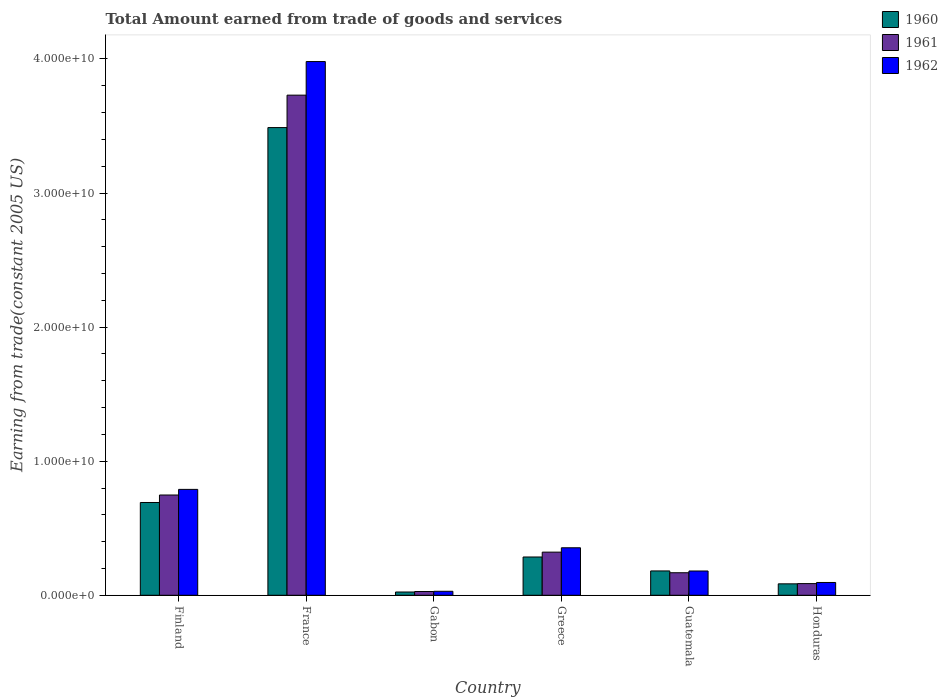How many different coloured bars are there?
Offer a terse response. 3. How many groups of bars are there?
Your answer should be very brief. 6. Are the number of bars on each tick of the X-axis equal?
Give a very brief answer. Yes. How many bars are there on the 6th tick from the left?
Your answer should be very brief. 3. What is the label of the 5th group of bars from the left?
Offer a terse response. Guatemala. What is the total amount earned by trading goods and services in 1962 in France?
Provide a short and direct response. 3.98e+1. Across all countries, what is the maximum total amount earned by trading goods and services in 1962?
Give a very brief answer. 3.98e+1. Across all countries, what is the minimum total amount earned by trading goods and services in 1960?
Keep it short and to the point. 2.44e+08. In which country was the total amount earned by trading goods and services in 1960 maximum?
Provide a succinct answer. France. In which country was the total amount earned by trading goods and services in 1961 minimum?
Offer a terse response. Gabon. What is the total total amount earned by trading goods and services in 1961 in the graph?
Your answer should be compact. 5.08e+1. What is the difference between the total amount earned by trading goods and services in 1960 in Finland and that in France?
Provide a short and direct response. -2.80e+1. What is the difference between the total amount earned by trading goods and services in 1961 in Guatemala and the total amount earned by trading goods and services in 1962 in Greece?
Provide a succinct answer. -1.86e+09. What is the average total amount earned by trading goods and services in 1961 per country?
Offer a terse response. 8.47e+09. What is the difference between the total amount earned by trading goods and services of/in 1960 and total amount earned by trading goods and services of/in 1962 in France?
Provide a short and direct response. -4.92e+09. What is the ratio of the total amount earned by trading goods and services in 1962 in France to that in Greece?
Offer a very short reply. 11.24. Is the total amount earned by trading goods and services in 1960 in Guatemala less than that in Honduras?
Your response must be concise. No. What is the difference between the highest and the second highest total amount earned by trading goods and services in 1962?
Make the answer very short. 3.63e+1. What is the difference between the highest and the lowest total amount earned by trading goods and services in 1960?
Your response must be concise. 3.46e+1. In how many countries, is the total amount earned by trading goods and services in 1962 greater than the average total amount earned by trading goods and services in 1962 taken over all countries?
Offer a terse response. 1. Is the sum of the total amount earned by trading goods and services in 1962 in France and Greece greater than the maximum total amount earned by trading goods and services in 1960 across all countries?
Provide a succinct answer. Yes. What does the 3rd bar from the right in Finland represents?
Keep it short and to the point. 1960. Are all the bars in the graph horizontal?
Provide a succinct answer. No. How many countries are there in the graph?
Your answer should be compact. 6. Are the values on the major ticks of Y-axis written in scientific E-notation?
Keep it short and to the point. Yes. How many legend labels are there?
Give a very brief answer. 3. How are the legend labels stacked?
Provide a short and direct response. Vertical. What is the title of the graph?
Your answer should be very brief. Total Amount earned from trade of goods and services. Does "2013" appear as one of the legend labels in the graph?
Ensure brevity in your answer.  No. What is the label or title of the X-axis?
Offer a very short reply. Country. What is the label or title of the Y-axis?
Keep it short and to the point. Earning from trade(constant 2005 US). What is the Earning from trade(constant 2005 US) of 1960 in Finland?
Your response must be concise. 6.92e+09. What is the Earning from trade(constant 2005 US) of 1961 in Finland?
Offer a terse response. 7.48e+09. What is the Earning from trade(constant 2005 US) of 1962 in Finland?
Keep it short and to the point. 7.90e+09. What is the Earning from trade(constant 2005 US) of 1960 in France?
Your answer should be compact. 3.49e+1. What is the Earning from trade(constant 2005 US) of 1961 in France?
Make the answer very short. 3.73e+1. What is the Earning from trade(constant 2005 US) in 1962 in France?
Your response must be concise. 3.98e+1. What is the Earning from trade(constant 2005 US) of 1960 in Gabon?
Your answer should be very brief. 2.44e+08. What is the Earning from trade(constant 2005 US) of 1961 in Gabon?
Provide a succinct answer. 2.80e+08. What is the Earning from trade(constant 2005 US) of 1962 in Gabon?
Keep it short and to the point. 2.97e+08. What is the Earning from trade(constant 2005 US) of 1960 in Greece?
Provide a short and direct response. 2.85e+09. What is the Earning from trade(constant 2005 US) in 1961 in Greece?
Keep it short and to the point. 3.22e+09. What is the Earning from trade(constant 2005 US) of 1962 in Greece?
Ensure brevity in your answer.  3.54e+09. What is the Earning from trade(constant 2005 US) of 1960 in Guatemala?
Offer a very short reply. 1.82e+09. What is the Earning from trade(constant 2005 US) in 1961 in Guatemala?
Your answer should be very brief. 1.68e+09. What is the Earning from trade(constant 2005 US) of 1962 in Guatemala?
Give a very brief answer. 1.81e+09. What is the Earning from trade(constant 2005 US) in 1960 in Honduras?
Ensure brevity in your answer.  8.53e+08. What is the Earning from trade(constant 2005 US) in 1961 in Honduras?
Ensure brevity in your answer.  8.71e+08. What is the Earning from trade(constant 2005 US) in 1962 in Honduras?
Your answer should be compact. 9.55e+08. Across all countries, what is the maximum Earning from trade(constant 2005 US) in 1960?
Your response must be concise. 3.49e+1. Across all countries, what is the maximum Earning from trade(constant 2005 US) of 1961?
Make the answer very short. 3.73e+1. Across all countries, what is the maximum Earning from trade(constant 2005 US) of 1962?
Keep it short and to the point. 3.98e+1. Across all countries, what is the minimum Earning from trade(constant 2005 US) in 1960?
Your answer should be very brief. 2.44e+08. Across all countries, what is the minimum Earning from trade(constant 2005 US) in 1961?
Your answer should be compact. 2.80e+08. Across all countries, what is the minimum Earning from trade(constant 2005 US) in 1962?
Your answer should be very brief. 2.97e+08. What is the total Earning from trade(constant 2005 US) of 1960 in the graph?
Offer a very short reply. 4.76e+1. What is the total Earning from trade(constant 2005 US) in 1961 in the graph?
Offer a very short reply. 5.08e+1. What is the total Earning from trade(constant 2005 US) in 1962 in the graph?
Offer a very short reply. 5.43e+1. What is the difference between the Earning from trade(constant 2005 US) of 1960 in Finland and that in France?
Give a very brief answer. -2.80e+1. What is the difference between the Earning from trade(constant 2005 US) of 1961 in Finland and that in France?
Make the answer very short. -2.98e+1. What is the difference between the Earning from trade(constant 2005 US) of 1962 in Finland and that in France?
Make the answer very short. -3.19e+1. What is the difference between the Earning from trade(constant 2005 US) of 1960 in Finland and that in Gabon?
Your answer should be very brief. 6.68e+09. What is the difference between the Earning from trade(constant 2005 US) in 1961 in Finland and that in Gabon?
Ensure brevity in your answer.  7.20e+09. What is the difference between the Earning from trade(constant 2005 US) in 1962 in Finland and that in Gabon?
Provide a short and direct response. 7.60e+09. What is the difference between the Earning from trade(constant 2005 US) in 1960 in Finland and that in Greece?
Give a very brief answer. 4.07e+09. What is the difference between the Earning from trade(constant 2005 US) of 1961 in Finland and that in Greece?
Give a very brief answer. 4.26e+09. What is the difference between the Earning from trade(constant 2005 US) in 1962 in Finland and that in Greece?
Keep it short and to the point. 4.35e+09. What is the difference between the Earning from trade(constant 2005 US) in 1960 in Finland and that in Guatemala?
Give a very brief answer. 5.11e+09. What is the difference between the Earning from trade(constant 2005 US) in 1961 in Finland and that in Guatemala?
Your answer should be compact. 5.80e+09. What is the difference between the Earning from trade(constant 2005 US) of 1962 in Finland and that in Guatemala?
Your response must be concise. 6.09e+09. What is the difference between the Earning from trade(constant 2005 US) of 1960 in Finland and that in Honduras?
Make the answer very short. 6.07e+09. What is the difference between the Earning from trade(constant 2005 US) of 1961 in Finland and that in Honduras?
Your response must be concise. 6.61e+09. What is the difference between the Earning from trade(constant 2005 US) in 1962 in Finland and that in Honduras?
Ensure brevity in your answer.  6.94e+09. What is the difference between the Earning from trade(constant 2005 US) in 1960 in France and that in Gabon?
Ensure brevity in your answer.  3.46e+1. What is the difference between the Earning from trade(constant 2005 US) of 1961 in France and that in Gabon?
Give a very brief answer. 3.70e+1. What is the difference between the Earning from trade(constant 2005 US) of 1962 in France and that in Gabon?
Offer a terse response. 3.95e+1. What is the difference between the Earning from trade(constant 2005 US) in 1960 in France and that in Greece?
Give a very brief answer. 3.20e+1. What is the difference between the Earning from trade(constant 2005 US) in 1961 in France and that in Greece?
Offer a terse response. 3.41e+1. What is the difference between the Earning from trade(constant 2005 US) of 1962 in France and that in Greece?
Offer a terse response. 3.63e+1. What is the difference between the Earning from trade(constant 2005 US) in 1960 in France and that in Guatemala?
Make the answer very short. 3.31e+1. What is the difference between the Earning from trade(constant 2005 US) in 1961 in France and that in Guatemala?
Offer a terse response. 3.56e+1. What is the difference between the Earning from trade(constant 2005 US) in 1962 in France and that in Guatemala?
Make the answer very short. 3.80e+1. What is the difference between the Earning from trade(constant 2005 US) in 1960 in France and that in Honduras?
Your answer should be very brief. 3.40e+1. What is the difference between the Earning from trade(constant 2005 US) in 1961 in France and that in Honduras?
Your answer should be compact. 3.64e+1. What is the difference between the Earning from trade(constant 2005 US) of 1962 in France and that in Honduras?
Make the answer very short. 3.89e+1. What is the difference between the Earning from trade(constant 2005 US) of 1960 in Gabon and that in Greece?
Your response must be concise. -2.61e+09. What is the difference between the Earning from trade(constant 2005 US) of 1961 in Gabon and that in Greece?
Your answer should be very brief. -2.94e+09. What is the difference between the Earning from trade(constant 2005 US) in 1962 in Gabon and that in Greece?
Your answer should be compact. -3.25e+09. What is the difference between the Earning from trade(constant 2005 US) of 1960 in Gabon and that in Guatemala?
Your answer should be compact. -1.57e+09. What is the difference between the Earning from trade(constant 2005 US) of 1961 in Gabon and that in Guatemala?
Ensure brevity in your answer.  -1.40e+09. What is the difference between the Earning from trade(constant 2005 US) in 1962 in Gabon and that in Guatemala?
Give a very brief answer. -1.51e+09. What is the difference between the Earning from trade(constant 2005 US) in 1960 in Gabon and that in Honduras?
Give a very brief answer. -6.09e+08. What is the difference between the Earning from trade(constant 2005 US) in 1961 in Gabon and that in Honduras?
Give a very brief answer. -5.91e+08. What is the difference between the Earning from trade(constant 2005 US) in 1962 in Gabon and that in Honduras?
Offer a terse response. -6.58e+08. What is the difference between the Earning from trade(constant 2005 US) in 1960 in Greece and that in Guatemala?
Make the answer very short. 1.04e+09. What is the difference between the Earning from trade(constant 2005 US) of 1961 in Greece and that in Guatemala?
Make the answer very short. 1.54e+09. What is the difference between the Earning from trade(constant 2005 US) in 1962 in Greece and that in Guatemala?
Give a very brief answer. 1.73e+09. What is the difference between the Earning from trade(constant 2005 US) of 1960 in Greece and that in Honduras?
Offer a very short reply. 2.00e+09. What is the difference between the Earning from trade(constant 2005 US) in 1961 in Greece and that in Honduras?
Provide a succinct answer. 2.35e+09. What is the difference between the Earning from trade(constant 2005 US) of 1962 in Greece and that in Honduras?
Offer a terse response. 2.59e+09. What is the difference between the Earning from trade(constant 2005 US) in 1960 in Guatemala and that in Honduras?
Give a very brief answer. 9.62e+08. What is the difference between the Earning from trade(constant 2005 US) of 1961 in Guatemala and that in Honduras?
Offer a terse response. 8.09e+08. What is the difference between the Earning from trade(constant 2005 US) in 1962 in Guatemala and that in Honduras?
Offer a very short reply. 8.56e+08. What is the difference between the Earning from trade(constant 2005 US) of 1960 in Finland and the Earning from trade(constant 2005 US) of 1961 in France?
Your response must be concise. -3.04e+1. What is the difference between the Earning from trade(constant 2005 US) of 1960 in Finland and the Earning from trade(constant 2005 US) of 1962 in France?
Keep it short and to the point. -3.29e+1. What is the difference between the Earning from trade(constant 2005 US) in 1961 in Finland and the Earning from trade(constant 2005 US) in 1962 in France?
Your response must be concise. -3.23e+1. What is the difference between the Earning from trade(constant 2005 US) in 1960 in Finland and the Earning from trade(constant 2005 US) in 1961 in Gabon?
Provide a succinct answer. 6.64e+09. What is the difference between the Earning from trade(constant 2005 US) in 1960 in Finland and the Earning from trade(constant 2005 US) in 1962 in Gabon?
Your answer should be compact. 6.62e+09. What is the difference between the Earning from trade(constant 2005 US) in 1961 in Finland and the Earning from trade(constant 2005 US) in 1962 in Gabon?
Give a very brief answer. 7.18e+09. What is the difference between the Earning from trade(constant 2005 US) of 1960 in Finland and the Earning from trade(constant 2005 US) of 1961 in Greece?
Offer a very short reply. 3.70e+09. What is the difference between the Earning from trade(constant 2005 US) of 1960 in Finland and the Earning from trade(constant 2005 US) of 1962 in Greece?
Give a very brief answer. 3.38e+09. What is the difference between the Earning from trade(constant 2005 US) of 1961 in Finland and the Earning from trade(constant 2005 US) of 1962 in Greece?
Your answer should be very brief. 3.93e+09. What is the difference between the Earning from trade(constant 2005 US) of 1960 in Finland and the Earning from trade(constant 2005 US) of 1961 in Guatemala?
Your answer should be very brief. 5.24e+09. What is the difference between the Earning from trade(constant 2005 US) of 1960 in Finland and the Earning from trade(constant 2005 US) of 1962 in Guatemala?
Your response must be concise. 5.11e+09. What is the difference between the Earning from trade(constant 2005 US) in 1961 in Finland and the Earning from trade(constant 2005 US) in 1962 in Guatemala?
Provide a succinct answer. 5.67e+09. What is the difference between the Earning from trade(constant 2005 US) of 1960 in Finland and the Earning from trade(constant 2005 US) of 1961 in Honduras?
Keep it short and to the point. 6.05e+09. What is the difference between the Earning from trade(constant 2005 US) of 1960 in Finland and the Earning from trade(constant 2005 US) of 1962 in Honduras?
Give a very brief answer. 5.97e+09. What is the difference between the Earning from trade(constant 2005 US) of 1961 in Finland and the Earning from trade(constant 2005 US) of 1962 in Honduras?
Provide a short and direct response. 6.52e+09. What is the difference between the Earning from trade(constant 2005 US) in 1960 in France and the Earning from trade(constant 2005 US) in 1961 in Gabon?
Make the answer very short. 3.46e+1. What is the difference between the Earning from trade(constant 2005 US) of 1960 in France and the Earning from trade(constant 2005 US) of 1962 in Gabon?
Your answer should be compact. 3.46e+1. What is the difference between the Earning from trade(constant 2005 US) in 1961 in France and the Earning from trade(constant 2005 US) in 1962 in Gabon?
Ensure brevity in your answer.  3.70e+1. What is the difference between the Earning from trade(constant 2005 US) of 1960 in France and the Earning from trade(constant 2005 US) of 1961 in Greece?
Your response must be concise. 3.17e+1. What is the difference between the Earning from trade(constant 2005 US) of 1960 in France and the Earning from trade(constant 2005 US) of 1962 in Greece?
Offer a very short reply. 3.13e+1. What is the difference between the Earning from trade(constant 2005 US) of 1961 in France and the Earning from trade(constant 2005 US) of 1962 in Greece?
Your answer should be compact. 3.38e+1. What is the difference between the Earning from trade(constant 2005 US) in 1960 in France and the Earning from trade(constant 2005 US) in 1961 in Guatemala?
Give a very brief answer. 3.32e+1. What is the difference between the Earning from trade(constant 2005 US) in 1960 in France and the Earning from trade(constant 2005 US) in 1962 in Guatemala?
Provide a succinct answer. 3.31e+1. What is the difference between the Earning from trade(constant 2005 US) in 1961 in France and the Earning from trade(constant 2005 US) in 1962 in Guatemala?
Give a very brief answer. 3.55e+1. What is the difference between the Earning from trade(constant 2005 US) in 1960 in France and the Earning from trade(constant 2005 US) in 1961 in Honduras?
Make the answer very short. 3.40e+1. What is the difference between the Earning from trade(constant 2005 US) of 1960 in France and the Earning from trade(constant 2005 US) of 1962 in Honduras?
Your answer should be compact. 3.39e+1. What is the difference between the Earning from trade(constant 2005 US) of 1961 in France and the Earning from trade(constant 2005 US) of 1962 in Honduras?
Your answer should be compact. 3.63e+1. What is the difference between the Earning from trade(constant 2005 US) of 1960 in Gabon and the Earning from trade(constant 2005 US) of 1961 in Greece?
Your answer should be very brief. -2.97e+09. What is the difference between the Earning from trade(constant 2005 US) of 1960 in Gabon and the Earning from trade(constant 2005 US) of 1962 in Greece?
Provide a short and direct response. -3.30e+09. What is the difference between the Earning from trade(constant 2005 US) in 1961 in Gabon and the Earning from trade(constant 2005 US) in 1962 in Greece?
Offer a terse response. -3.26e+09. What is the difference between the Earning from trade(constant 2005 US) of 1960 in Gabon and the Earning from trade(constant 2005 US) of 1961 in Guatemala?
Give a very brief answer. -1.44e+09. What is the difference between the Earning from trade(constant 2005 US) in 1960 in Gabon and the Earning from trade(constant 2005 US) in 1962 in Guatemala?
Offer a very short reply. -1.57e+09. What is the difference between the Earning from trade(constant 2005 US) of 1961 in Gabon and the Earning from trade(constant 2005 US) of 1962 in Guatemala?
Keep it short and to the point. -1.53e+09. What is the difference between the Earning from trade(constant 2005 US) in 1960 in Gabon and the Earning from trade(constant 2005 US) in 1961 in Honduras?
Make the answer very short. -6.27e+08. What is the difference between the Earning from trade(constant 2005 US) in 1960 in Gabon and the Earning from trade(constant 2005 US) in 1962 in Honduras?
Your answer should be very brief. -7.11e+08. What is the difference between the Earning from trade(constant 2005 US) in 1961 in Gabon and the Earning from trade(constant 2005 US) in 1962 in Honduras?
Offer a terse response. -6.74e+08. What is the difference between the Earning from trade(constant 2005 US) in 1960 in Greece and the Earning from trade(constant 2005 US) in 1961 in Guatemala?
Your answer should be very brief. 1.17e+09. What is the difference between the Earning from trade(constant 2005 US) in 1960 in Greece and the Earning from trade(constant 2005 US) in 1962 in Guatemala?
Offer a terse response. 1.04e+09. What is the difference between the Earning from trade(constant 2005 US) of 1961 in Greece and the Earning from trade(constant 2005 US) of 1962 in Guatemala?
Offer a very short reply. 1.41e+09. What is the difference between the Earning from trade(constant 2005 US) in 1960 in Greece and the Earning from trade(constant 2005 US) in 1961 in Honduras?
Ensure brevity in your answer.  1.98e+09. What is the difference between the Earning from trade(constant 2005 US) of 1960 in Greece and the Earning from trade(constant 2005 US) of 1962 in Honduras?
Keep it short and to the point. 1.90e+09. What is the difference between the Earning from trade(constant 2005 US) in 1961 in Greece and the Earning from trade(constant 2005 US) in 1962 in Honduras?
Give a very brief answer. 2.26e+09. What is the difference between the Earning from trade(constant 2005 US) in 1960 in Guatemala and the Earning from trade(constant 2005 US) in 1961 in Honduras?
Make the answer very short. 9.44e+08. What is the difference between the Earning from trade(constant 2005 US) of 1960 in Guatemala and the Earning from trade(constant 2005 US) of 1962 in Honduras?
Your answer should be very brief. 8.61e+08. What is the difference between the Earning from trade(constant 2005 US) of 1961 in Guatemala and the Earning from trade(constant 2005 US) of 1962 in Honduras?
Make the answer very short. 7.26e+08. What is the average Earning from trade(constant 2005 US) in 1960 per country?
Keep it short and to the point. 7.93e+09. What is the average Earning from trade(constant 2005 US) in 1961 per country?
Provide a succinct answer. 8.47e+09. What is the average Earning from trade(constant 2005 US) in 1962 per country?
Make the answer very short. 9.05e+09. What is the difference between the Earning from trade(constant 2005 US) in 1960 and Earning from trade(constant 2005 US) in 1961 in Finland?
Offer a terse response. -5.58e+08. What is the difference between the Earning from trade(constant 2005 US) of 1960 and Earning from trade(constant 2005 US) of 1962 in Finland?
Provide a short and direct response. -9.78e+08. What is the difference between the Earning from trade(constant 2005 US) in 1961 and Earning from trade(constant 2005 US) in 1962 in Finland?
Give a very brief answer. -4.20e+08. What is the difference between the Earning from trade(constant 2005 US) in 1960 and Earning from trade(constant 2005 US) in 1961 in France?
Your answer should be compact. -2.42e+09. What is the difference between the Earning from trade(constant 2005 US) of 1960 and Earning from trade(constant 2005 US) of 1962 in France?
Your answer should be very brief. -4.92e+09. What is the difference between the Earning from trade(constant 2005 US) of 1961 and Earning from trade(constant 2005 US) of 1962 in France?
Make the answer very short. -2.50e+09. What is the difference between the Earning from trade(constant 2005 US) of 1960 and Earning from trade(constant 2005 US) of 1961 in Gabon?
Offer a very short reply. -3.66e+07. What is the difference between the Earning from trade(constant 2005 US) of 1960 and Earning from trade(constant 2005 US) of 1962 in Gabon?
Provide a succinct answer. -5.31e+07. What is the difference between the Earning from trade(constant 2005 US) in 1961 and Earning from trade(constant 2005 US) in 1962 in Gabon?
Provide a short and direct response. -1.64e+07. What is the difference between the Earning from trade(constant 2005 US) of 1960 and Earning from trade(constant 2005 US) of 1961 in Greece?
Offer a terse response. -3.63e+08. What is the difference between the Earning from trade(constant 2005 US) of 1960 and Earning from trade(constant 2005 US) of 1962 in Greece?
Ensure brevity in your answer.  -6.88e+08. What is the difference between the Earning from trade(constant 2005 US) in 1961 and Earning from trade(constant 2005 US) in 1962 in Greece?
Give a very brief answer. -3.25e+08. What is the difference between the Earning from trade(constant 2005 US) of 1960 and Earning from trade(constant 2005 US) of 1961 in Guatemala?
Your answer should be compact. 1.35e+08. What is the difference between the Earning from trade(constant 2005 US) of 1960 and Earning from trade(constant 2005 US) of 1962 in Guatemala?
Make the answer very short. 4.40e+06. What is the difference between the Earning from trade(constant 2005 US) in 1961 and Earning from trade(constant 2005 US) in 1962 in Guatemala?
Your answer should be compact. -1.31e+08. What is the difference between the Earning from trade(constant 2005 US) of 1960 and Earning from trade(constant 2005 US) of 1961 in Honduras?
Give a very brief answer. -1.81e+07. What is the difference between the Earning from trade(constant 2005 US) of 1960 and Earning from trade(constant 2005 US) of 1962 in Honduras?
Provide a short and direct response. -1.02e+08. What is the difference between the Earning from trade(constant 2005 US) in 1961 and Earning from trade(constant 2005 US) in 1962 in Honduras?
Offer a very short reply. -8.35e+07. What is the ratio of the Earning from trade(constant 2005 US) in 1960 in Finland to that in France?
Make the answer very short. 0.2. What is the ratio of the Earning from trade(constant 2005 US) in 1961 in Finland to that in France?
Ensure brevity in your answer.  0.2. What is the ratio of the Earning from trade(constant 2005 US) in 1962 in Finland to that in France?
Give a very brief answer. 0.2. What is the ratio of the Earning from trade(constant 2005 US) in 1960 in Finland to that in Gabon?
Your answer should be compact. 28.38. What is the ratio of the Earning from trade(constant 2005 US) in 1961 in Finland to that in Gabon?
Keep it short and to the point. 26.67. What is the ratio of the Earning from trade(constant 2005 US) in 1962 in Finland to that in Gabon?
Ensure brevity in your answer.  26.6. What is the ratio of the Earning from trade(constant 2005 US) in 1960 in Finland to that in Greece?
Your response must be concise. 2.42. What is the ratio of the Earning from trade(constant 2005 US) of 1961 in Finland to that in Greece?
Your answer should be compact. 2.32. What is the ratio of the Earning from trade(constant 2005 US) of 1962 in Finland to that in Greece?
Provide a succinct answer. 2.23. What is the ratio of the Earning from trade(constant 2005 US) of 1960 in Finland to that in Guatemala?
Make the answer very short. 3.81. What is the ratio of the Earning from trade(constant 2005 US) in 1961 in Finland to that in Guatemala?
Offer a terse response. 4.45. What is the ratio of the Earning from trade(constant 2005 US) of 1962 in Finland to that in Guatemala?
Your response must be concise. 4.36. What is the ratio of the Earning from trade(constant 2005 US) of 1960 in Finland to that in Honduras?
Your response must be concise. 8.11. What is the ratio of the Earning from trade(constant 2005 US) in 1961 in Finland to that in Honduras?
Provide a succinct answer. 8.58. What is the ratio of the Earning from trade(constant 2005 US) of 1962 in Finland to that in Honduras?
Ensure brevity in your answer.  8.27. What is the ratio of the Earning from trade(constant 2005 US) in 1960 in France to that in Gabon?
Offer a terse response. 143.08. What is the ratio of the Earning from trade(constant 2005 US) of 1961 in France to that in Gabon?
Offer a terse response. 133.02. What is the ratio of the Earning from trade(constant 2005 US) of 1962 in France to that in Gabon?
Your answer should be compact. 134.1. What is the ratio of the Earning from trade(constant 2005 US) of 1960 in France to that in Greece?
Your answer should be compact. 12.22. What is the ratio of the Earning from trade(constant 2005 US) of 1961 in France to that in Greece?
Give a very brief answer. 11.59. What is the ratio of the Earning from trade(constant 2005 US) in 1962 in France to that in Greece?
Offer a terse response. 11.24. What is the ratio of the Earning from trade(constant 2005 US) of 1960 in France to that in Guatemala?
Ensure brevity in your answer.  19.22. What is the ratio of the Earning from trade(constant 2005 US) of 1961 in France to that in Guatemala?
Make the answer very short. 22.2. What is the ratio of the Earning from trade(constant 2005 US) of 1962 in France to that in Guatemala?
Your answer should be compact. 21.98. What is the ratio of the Earning from trade(constant 2005 US) of 1960 in France to that in Honduras?
Provide a short and direct response. 40.9. What is the ratio of the Earning from trade(constant 2005 US) of 1961 in France to that in Honduras?
Your response must be concise. 42.82. What is the ratio of the Earning from trade(constant 2005 US) in 1962 in France to that in Honduras?
Ensure brevity in your answer.  41.7. What is the ratio of the Earning from trade(constant 2005 US) in 1960 in Gabon to that in Greece?
Your response must be concise. 0.09. What is the ratio of the Earning from trade(constant 2005 US) in 1961 in Gabon to that in Greece?
Ensure brevity in your answer.  0.09. What is the ratio of the Earning from trade(constant 2005 US) of 1962 in Gabon to that in Greece?
Provide a succinct answer. 0.08. What is the ratio of the Earning from trade(constant 2005 US) of 1960 in Gabon to that in Guatemala?
Keep it short and to the point. 0.13. What is the ratio of the Earning from trade(constant 2005 US) of 1961 in Gabon to that in Guatemala?
Ensure brevity in your answer.  0.17. What is the ratio of the Earning from trade(constant 2005 US) of 1962 in Gabon to that in Guatemala?
Keep it short and to the point. 0.16. What is the ratio of the Earning from trade(constant 2005 US) of 1960 in Gabon to that in Honduras?
Provide a succinct answer. 0.29. What is the ratio of the Earning from trade(constant 2005 US) in 1961 in Gabon to that in Honduras?
Provide a short and direct response. 0.32. What is the ratio of the Earning from trade(constant 2005 US) of 1962 in Gabon to that in Honduras?
Make the answer very short. 0.31. What is the ratio of the Earning from trade(constant 2005 US) of 1960 in Greece to that in Guatemala?
Ensure brevity in your answer.  1.57. What is the ratio of the Earning from trade(constant 2005 US) in 1961 in Greece to that in Guatemala?
Your answer should be very brief. 1.92. What is the ratio of the Earning from trade(constant 2005 US) of 1962 in Greece to that in Guatemala?
Ensure brevity in your answer.  1.96. What is the ratio of the Earning from trade(constant 2005 US) in 1960 in Greece to that in Honduras?
Give a very brief answer. 3.35. What is the ratio of the Earning from trade(constant 2005 US) in 1961 in Greece to that in Honduras?
Your answer should be compact. 3.69. What is the ratio of the Earning from trade(constant 2005 US) in 1962 in Greece to that in Honduras?
Your answer should be compact. 3.71. What is the ratio of the Earning from trade(constant 2005 US) of 1960 in Guatemala to that in Honduras?
Your answer should be compact. 2.13. What is the ratio of the Earning from trade(constant 2005 US) of 1961 in Guatemala to that in Honduras?
Your answer should be compact. 1.93. What is the ratio of the Earning from trade(constant 2005 US) of 1962 in Guatemala to that in Honduras?
Offer a very short reply. 1.9. What is the difference between the highest and the second highest Earning from trade(constant 2005 US) of 1960?
Give a very brief answer. 2.80e+1. What is the difference between the highest and the second highest Earning from trade(constant 2005 US) of 1961?
Provide a succinct answer. 2.98e+1. What is the difference between the highest and the second highest Earning from trade(constant 2005 US) in 1962?
Keep it short and to the point. 3.19e+1. What is the difference between the highest and the lowest Earning from trade(constant 2005 US) of 1960?
Offer a very short reply. 3.46e+1. What is the difference between the highest and the lowest Earning from trade(constant 2005 US) of 1961?
Ensure brevity in your answer.  3.70e+1. What is the difference between the highest and the lowest Earning from trade(constant 2005 US) in 1962?
Ensure brevity in your answer.  3.95e+1. 